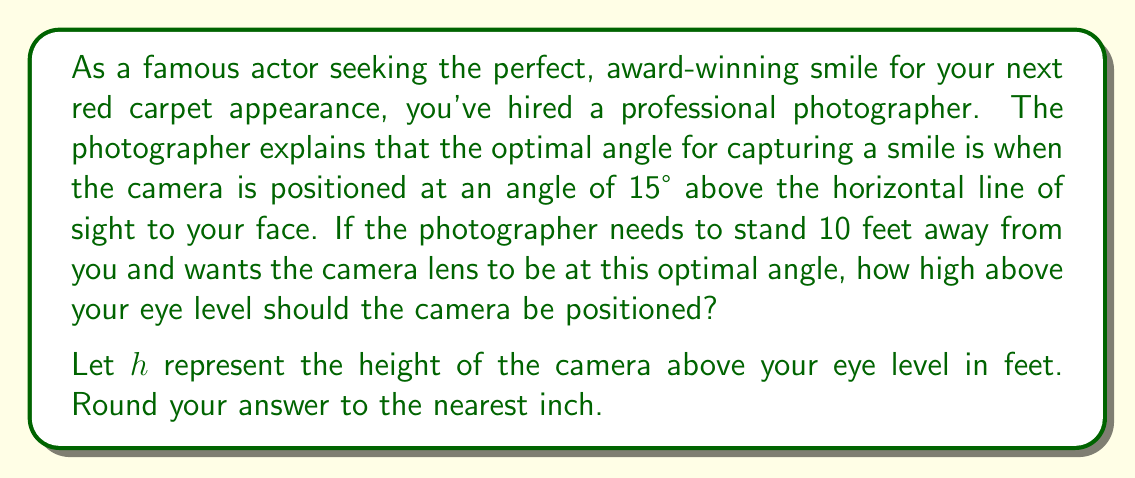Show me your answer to this math problem. To solve this problem, we need to use trigonometry. Let's break it down step-by-step:

1) We can visualize this scenario as a right triangle, where:
   - The base of the triangle is the horizontal distance from you to the photographer (10 feet)
   - The height of the triangle is the distance the camera needs to be above your eye level ($h$)
   - The angle between the base and the hypotenuse is 15°

2) In this right triangle, we're looking for the opposite side (height) given the adjacent side (distance) and the angle. This calls for the tangent function.

3) The tangent of an angle in a right triangle is defined as:

   $$\tan(\theta) = \frac{\text{opposite}}{\text{adjacent}}$$

4) Plugging in our known values:

   $$\tan(15°) = \frac{h}{10}$$

5) To solve for $h$, we multiply both sides by 10:

   $$10 \cdot \tan(15°) = h$$

6) Now we can calculate:
   
   $$h = 10 \cdot \tan(15°) \approx 10 \cdot 0.2679 \approx 2.679 \text{ feet}$$

7) Converting to inches (1 foot = 12 inches):
   
   $$2.679 \text{ feet} \cdot 12 \text{ inches/foot} \approx 32.148 \text{ inches}$$

8) Rounding to the nearest inch:

   $$32.148 \text{ inches} \approx 32 \text{ inches}$$
Answer: The camera should be positioned 32 inches above your eye level. 